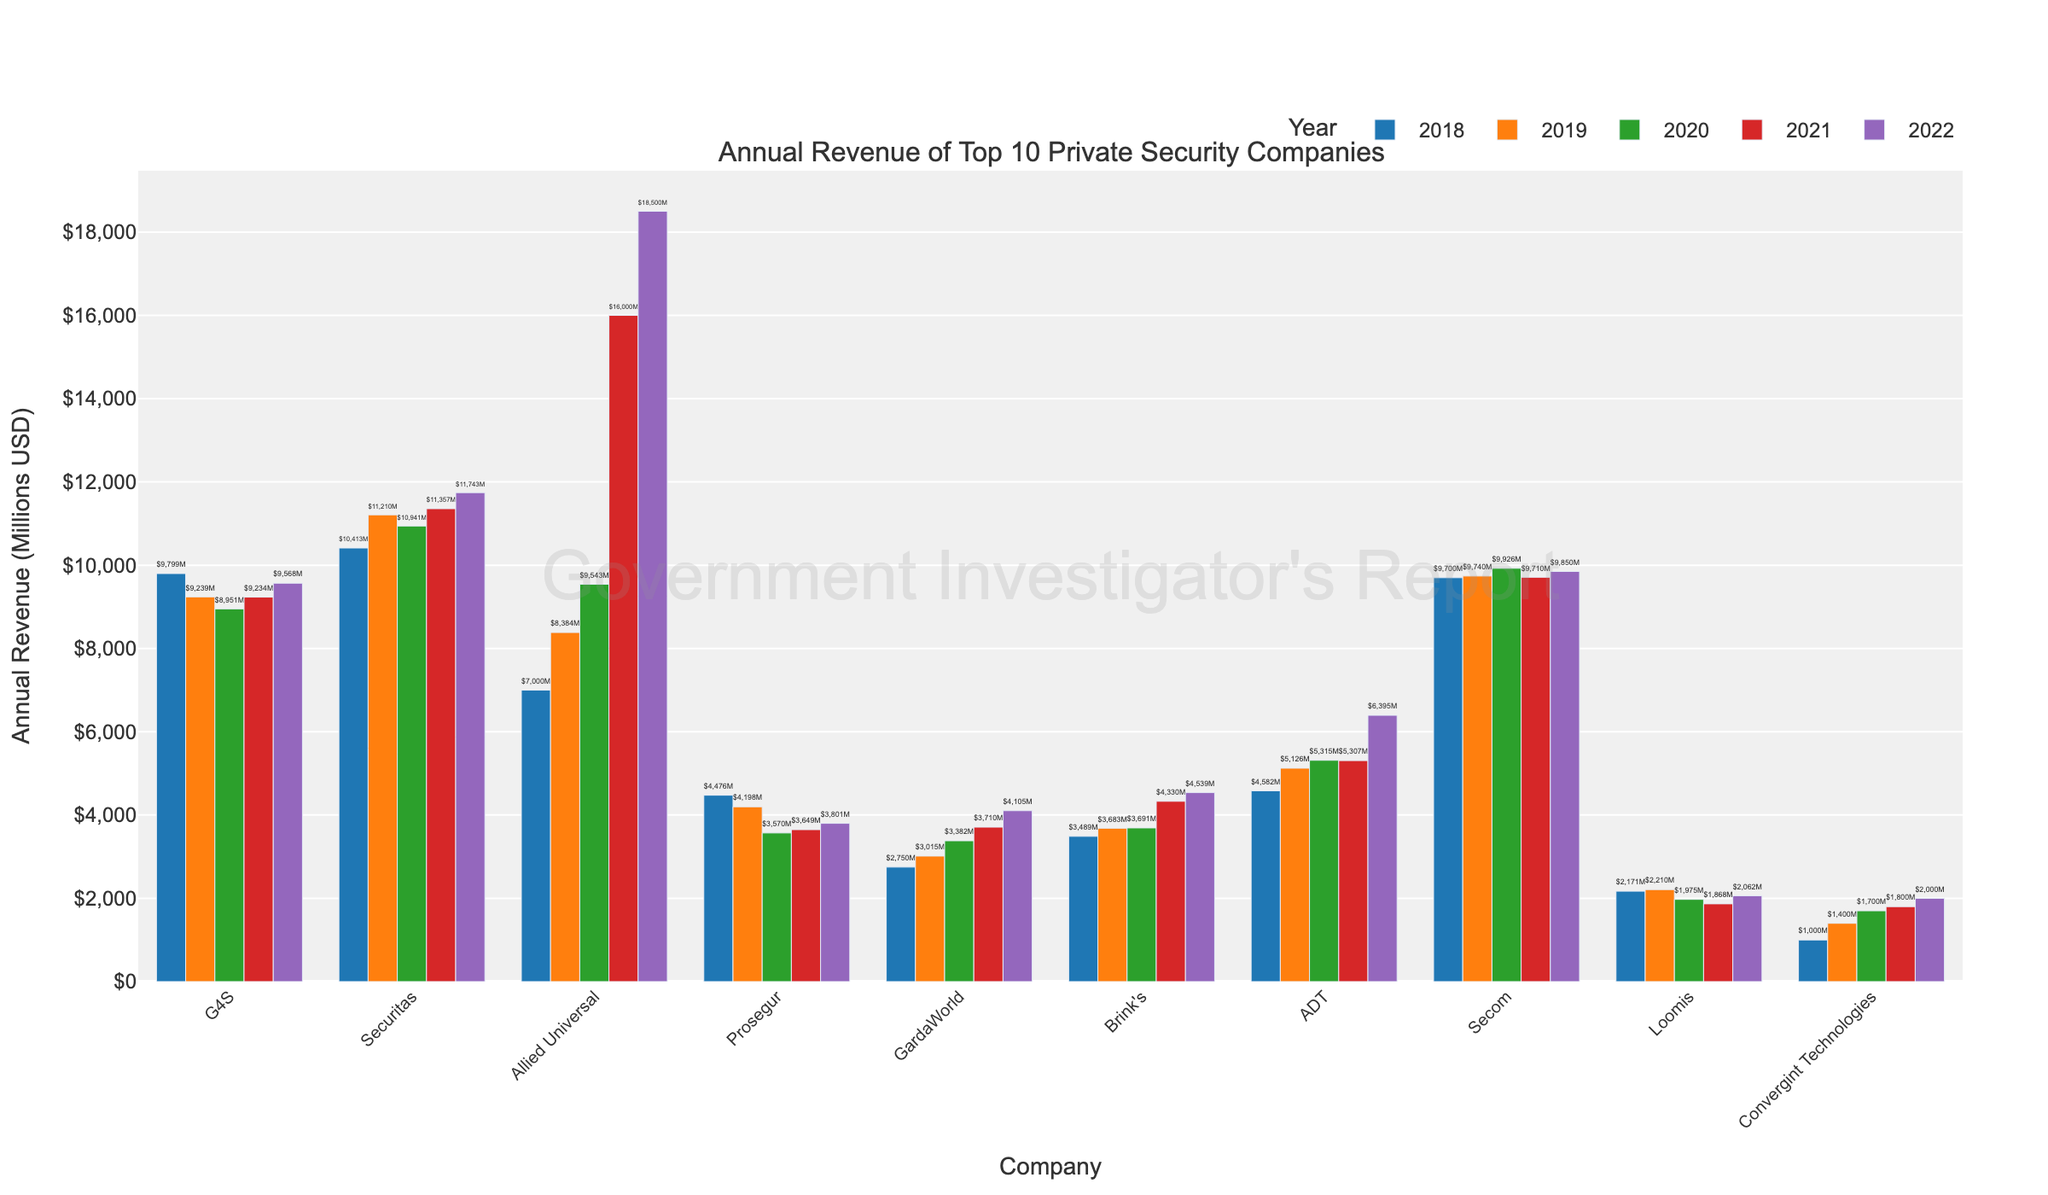Which company had the highest revenue in 2022? To determine this, look at the bar heights for the year 2022 across all companies. The tallest bar represents the company with the highest revenue.
Answer: Allied Universal Which company had the lowest revenue in 2020? Compare the bar heights for the year 2020 across all companies. The shortest bar indicates the company with the lowest revenue.
Answer: Loomis What is the difference in revenue between Securitas and G4S in 2019? Locate the bars for Securitas and G4S in the year 2019. Subtract the revenue of G4S from the revenue of Securitas.
Answer: 1971 million USD Which two companies showed the greatest increase in revenue from 2020 to 2021? Identify the bars for each company in 2020 and 2021, then calculate the increase in revenue for each company. Compare the changes and find the two highest.
Answer: Allied Universal and Brink's What is the average revenue of Prosegur over the five years? Sum the revenues for Prosegur from 2018 to 2022 and then divide by 5. ((4476 + 4198 + 3570 + 3649 + 3801) / 5)
Answer: 3938.8 million USD By how much did Allied Universal's revenue increase from 2019 to 2022? Find the revenue of Allied Universal for the years 2019 and 2022, then subtract the 2019 value from the 2022 value. (18500 - 8384)
Answer: 10116 million USD Which company had a consistent increase in revenue every year from 2018 to 2022? Examine the bars of each company for each year to see which company’s revenue increases every consecutive year.
Answer: Allied Universal What is the total revenue for GardaWorld for the five years combined? Sum all the annual revenues for GardaWorld from 2018 to 2022. (2750 + 3015 + 3382 + 3710 + 4105)
Answer: 16962 million USD Which year did Loomis have their lowest recorded revenue? Look at the bar heights for Loomis across all years and find the smallest bar.
Answer: 2021 Between Secom and ADT, which company had higher revenue in 2021, and what is the difference? Compare the bars of Secom and ADT for the year 2021 and subtract the lower value from the higher value. (9860 - 5307)
Answer: Secom, 3603 million USD 